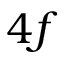<formula> <loc_0><loc_0><loc_500><loc_500>4 f</formula> 